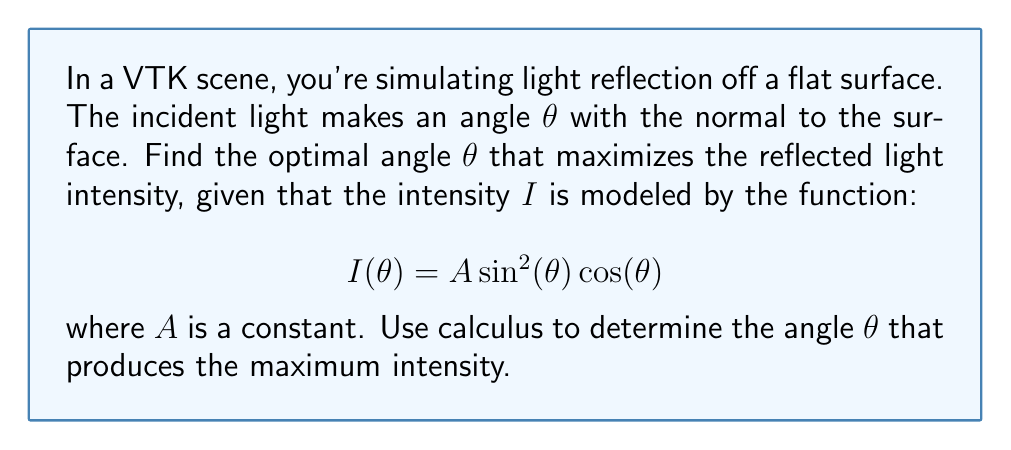Can you solve this math problem? To find the optimal angle for maximum light reflection, we need to follow these steps:

1) First, we need to find the derivative of $I(\theta)$ with respect to $\theta$:

   $$\frac{dI}{d\theta} = A \frac{d}{d\theta}[\sin^2(\theta) \cos(\theta)]$$

2) Using the product rule and chain rule:

   $$\frac{dI}{d\theta} = A [2\sin(\theta)\cos^2(\theta) - \sin^3(\theta)]$$

3) For the maximum intensity, we set this derivative to zero:

   $$A [2\sin(\theta)\cos^2(\theta) - \sin^3(\theta)] = 0$$

4) Factor out $A\sin(\theta)$ (assuming $A \neq 0$ and $\sin(\theta) \neq 0$):

   $$A\sin(\theta)[2\cos^2(\theta) - \sin^2(\theta)] = 0$$

5) Using the identity $\sin^2(\theta) + \cos^2(\theta) = 1$, we can replace $\sin^2(\theta)$ with $1 - \cos^2(\theta)$:

   $$2\cos^2(\theta) - (1 - \cos^2(\theta)) = 0$$

6) Simplify:

   $$3\cos^2(\theta) - 1 = 0$$

7) Solve for $\cos^2(\theta)$:

   $$\cos^2(\theta) = \frac{1}{3}$$

8) Take the square root of both sides:

   $$\cos(\theta) = \frac{1}{\sqrt{3}}$$

9) Finally, take the inverse cosine (arccos) of both sides:

   $$\theta = \arccos(\frac{1}{\sqrt{3}})$$

To confirm this is a maximum (not a minimum), we could check the second derivative is negative at this point, but this step is omitted for brevity.
Answer: $\theta = \arccos(\frac{1}{\sqrt{3}})$ 